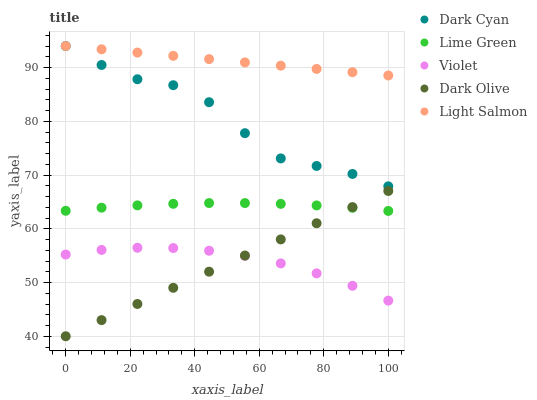Does Dark Olive have the minimum area under the curve?
Answer yes or no. Yes. Does Light Salmon have the maximum area under the curve?
Answer yes or no. Yes. Does Light Salmon have the minimum area under the curve?
Answer yes or no. No. Does Dark Olive have the maximum area under the curve?
Answer yes or no. No. Is Dark Olive the smoothest?
Answer yes or no. Yes. Is Dark Cyan the roughest?
Answer yes or no. Yes. Is Light Salmon the smoothest?
Answer yes or no. No. Is Light Salmon the roughest?
Answer yes or no. No. Does Dark Olive have the lowest value?
Answer yes or no. Yes. Does Light Salmon have the lowest value?
Answer yes or no. No. Does Light Salmon have the highest value?
Answer yes or no. Yes. Does Dark Olive have the highest value?
Answer yes or no. No. Is Dark Olive less than Light Salmon?
Answer yes or no. Yes. Is Dark Cyan greater than Lime Green?
Answer yes or no. Yes. Does Violet intersect Dark Olive?
Answer yes or no. Yes. Is Violet less than Dark Olive?
Answer yes or no. No. Is Violet greater than Dark Olive?
Answer yes or no. No. Does Dark Olive intersect Light Salmon?
Answer yes or no. No. 